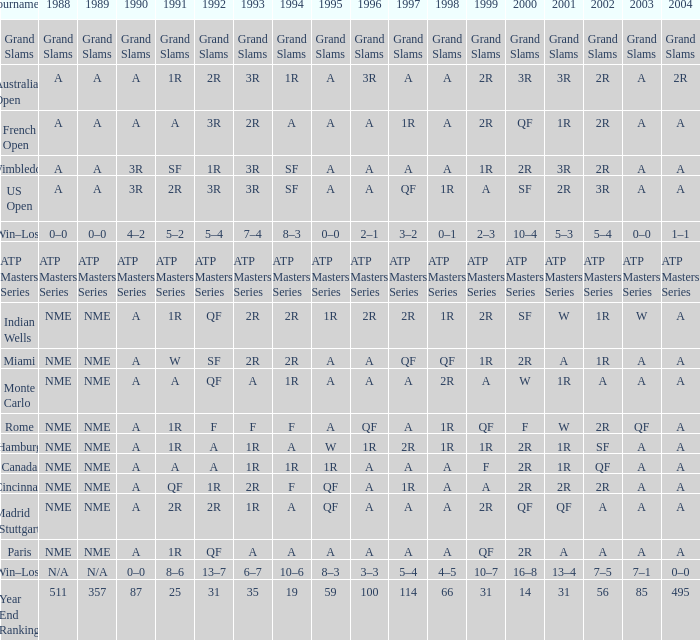What demonstrates for 1992 when 2001 is 1r, 1994 is 1r, and the 2002 is qf? A. 